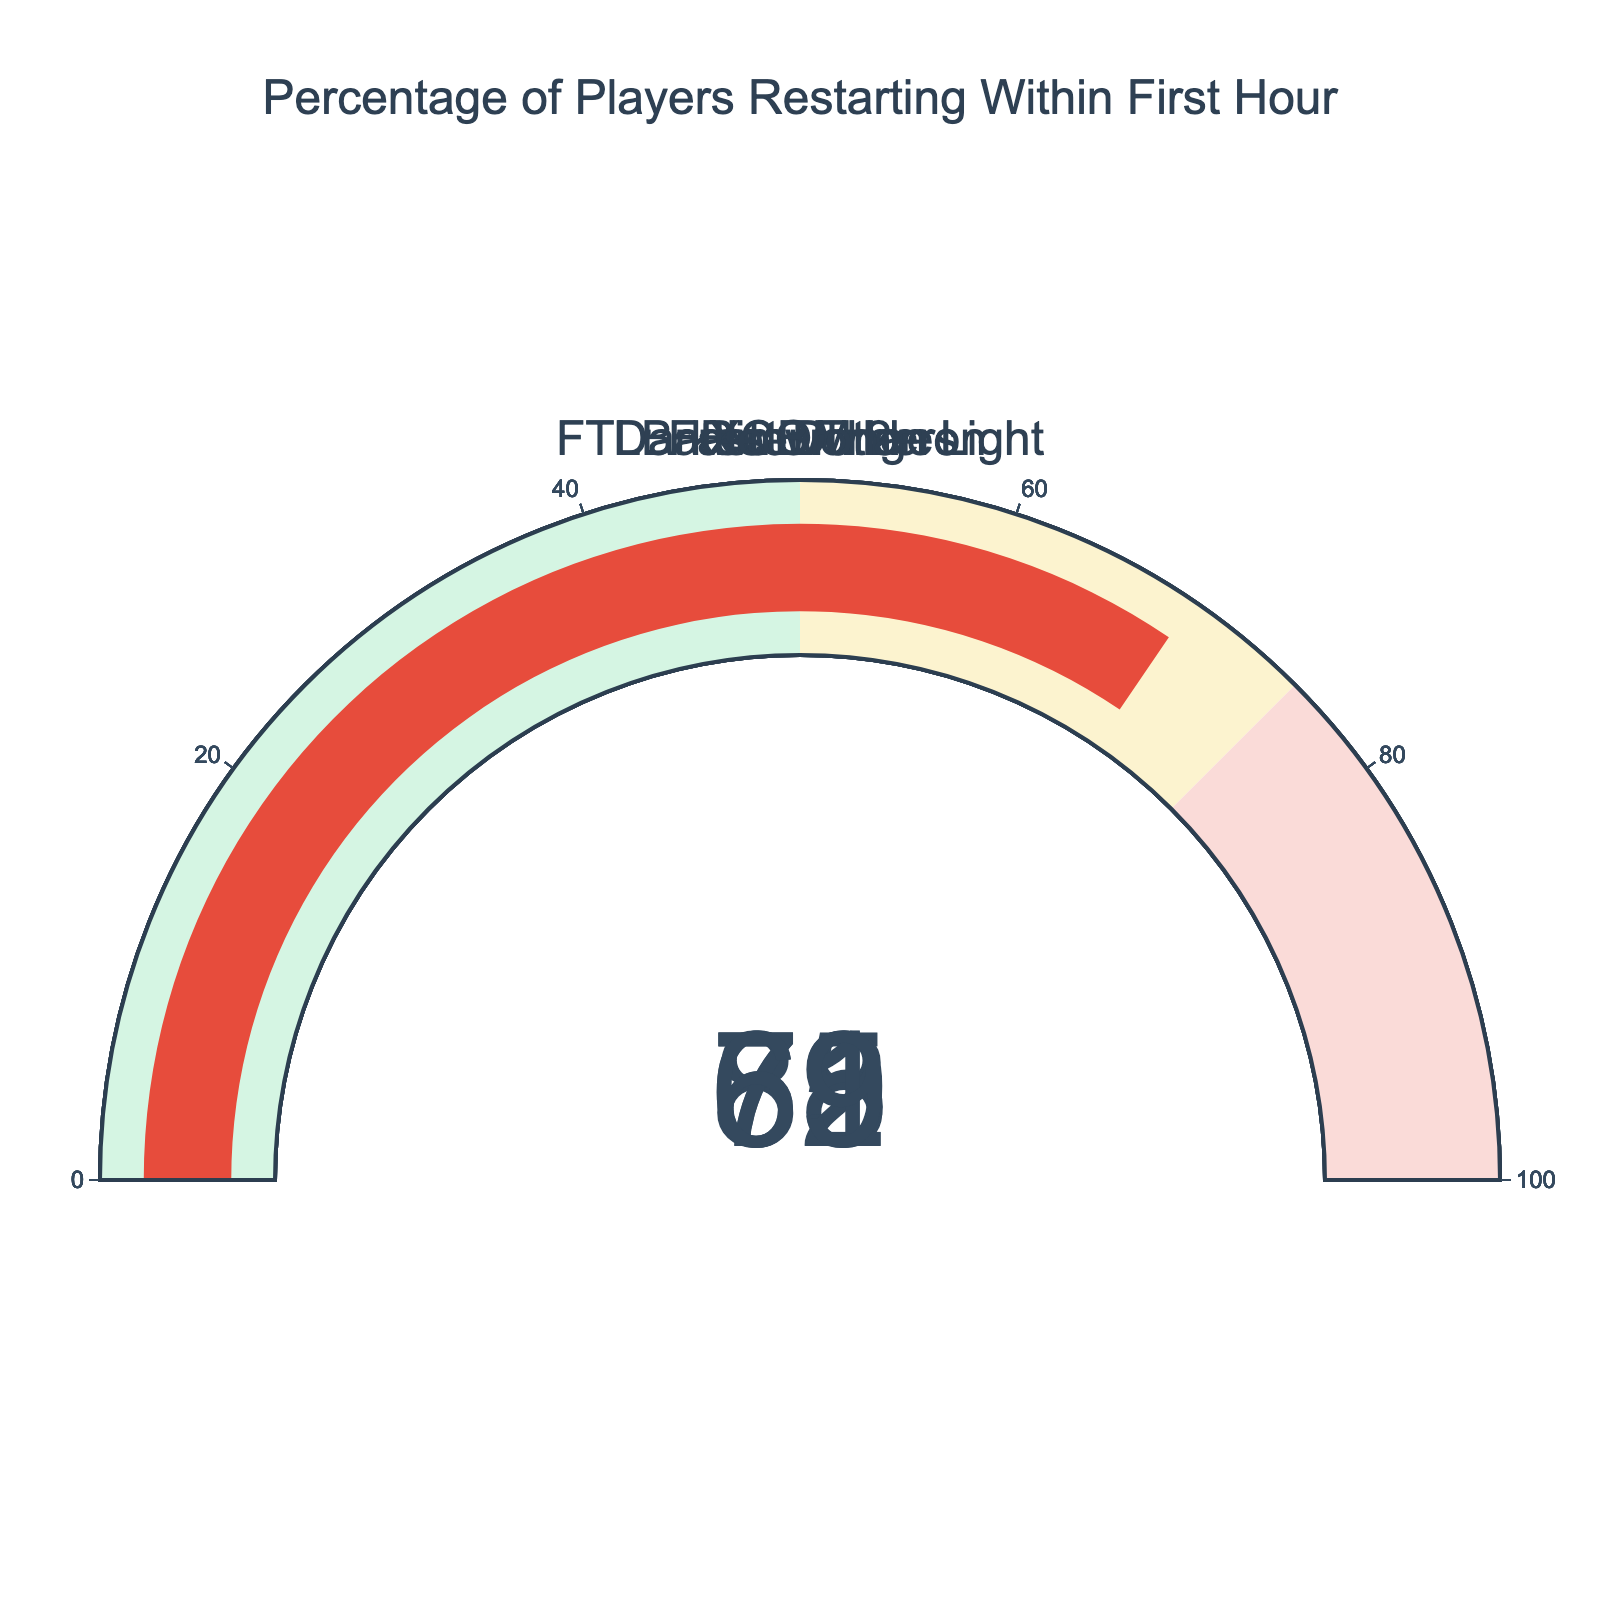Who has the highest restart percentage within the first hour? To find the highest restart percentage, look at the values on each gauge and identify the largest one. Darkest Dungeon shows 82%, which is the highest.
Answer: Darkest Dungeon How many games have a restart percentage above 70%? Identify games with restart percentages above 70% by looking at each gauge. XCOM 2 (78%), Darkest Dungeon (82%), and FTL: Faster Than Light (71%) all qualify.
Answer: 3 Which game has the lowest restart percentage? Compare the restart percentages on each gauge and find the smallest value. Rimworld shows 65%, which is the lowest.
Answer: Rimworld What is the average restart percentage of all the games? Restart_Percentages are 78, 65, 82, 71, 69. Sum these values: 78 + 65 + 82 + 71 + 69 = 365. Then, divide by the number of games (5). 365 / 5 = 73.
Answer: 73 How much higher is Darkest Dungeon's restart percentage compared to Rimworld's? Subtract Rimworld's restart percentage from Darkest Dungeon's: 82 (Darkest Dungeon) - 65 (Rimworld) = 17.
Answer: 17 Which games have a restart percentage that falls between 65% and 75%? Identify games with restart percentages between 65% and 75%. Rimworld (65%), FTL: Faster Than Light (71%), and Battle Brothers (69%) all fall within this range.
Answer: Rimworld, FTL: Faster Than Light, Battle Brothers What is the difference in restart percentage between the game with the second highest and the game with the second lowest restart percentage? The second highest is XCOM 2 with 78%. The second lowest is Battle Brothers with 69%. Find the difference: 78 - 69 = 9.
Answer: 9 What is the median restart percentage of these games? Arrange the percentages in ascending order: 65 (Rimworld), 69 (Battle Brothers), 71 (FTL: Faster Than Light), 78 (XCOM 2), 82 (Darkest Dungeon). The median value is the middle one, which is 71.
Answer: 71 